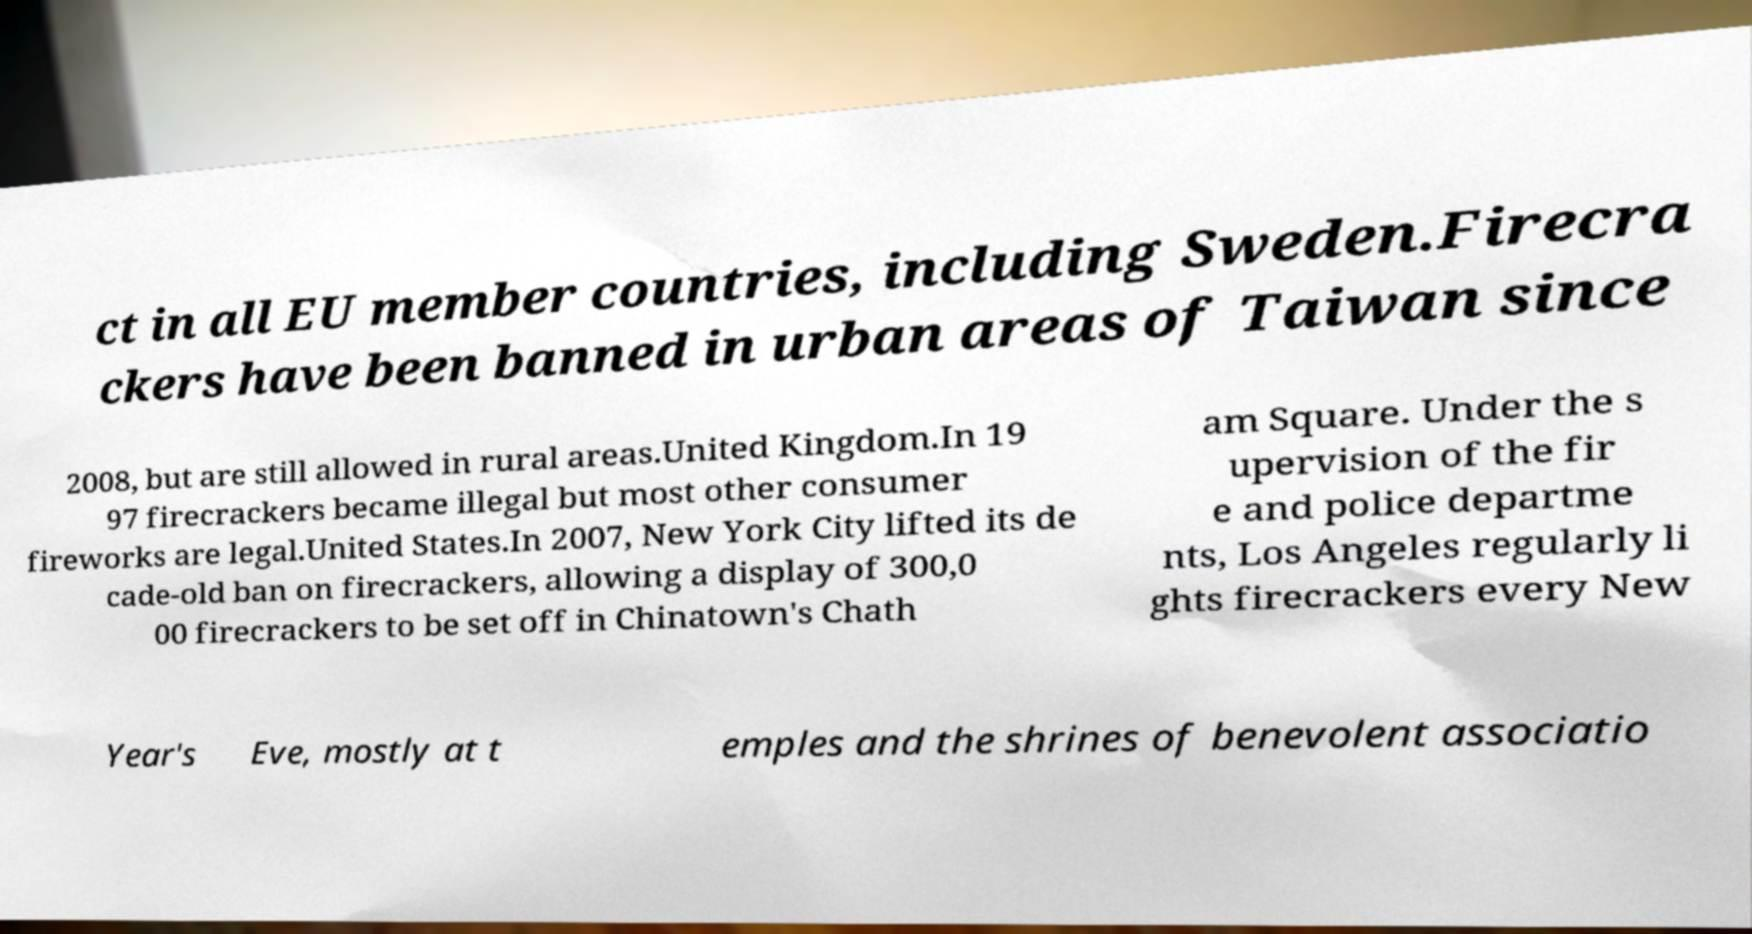Could you assist in decoding the text presented in this image and type it out clearly? ct in all EU member countries, including Sweden.Firecra ckers have been banned in urban areas of Taiwan since 2008, but are still allowed in rural areas.United Kingdom.In 19 97 firecrackers became illegal but most other consumer fireworks are legal.United States.In 2007, New York City lifted its de cade-old ban on firecrackers, allowing a display of 300,0 00 firecrackers to be set off in Chinatown's Chath am Square. Under the s upervision of the fir e and police departme nts, Los Angeles regularly li ghts firecrackers every New Year's Eve, mostly at t emples and the shrines of benevolent associatio 